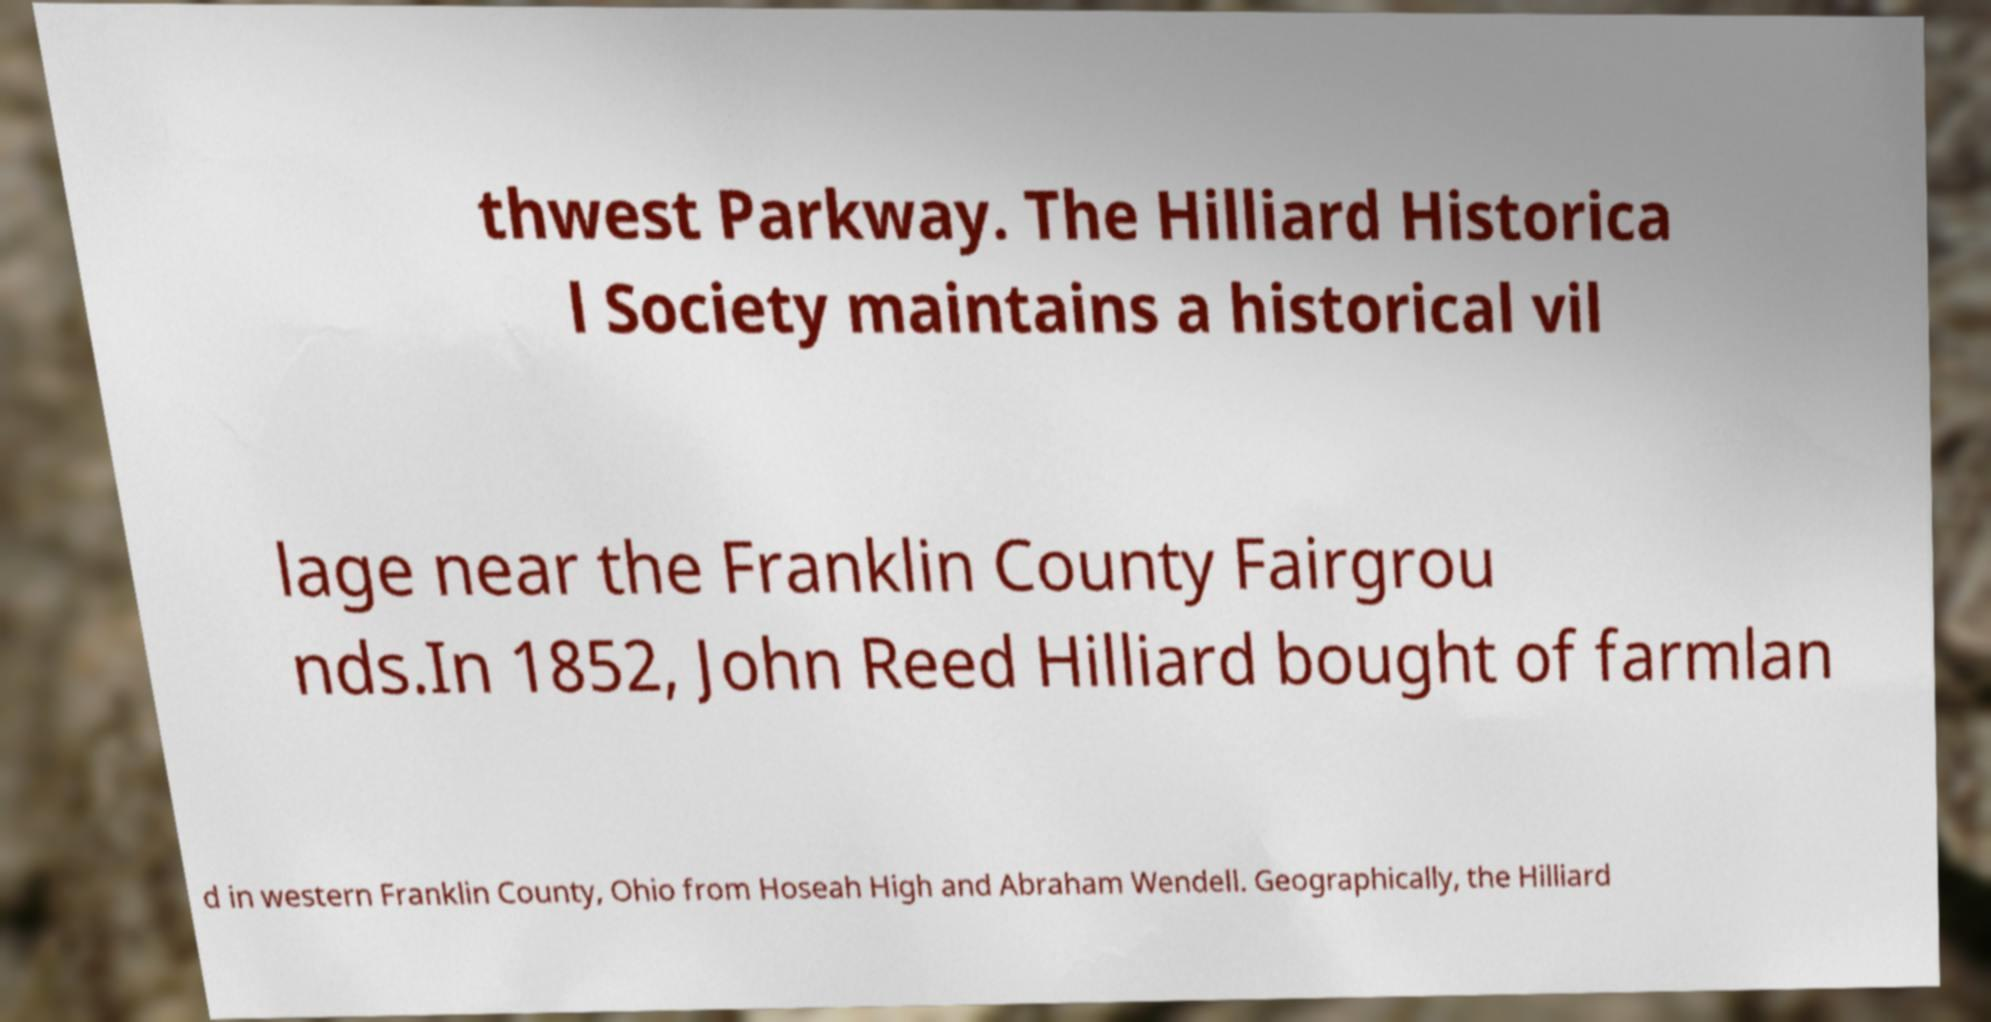Could you assist in decoding the text presented in this image and type it out clearly? thwest Parkway. The Hilliard Historica l Society maintains a historical vil lage near the Franklin County Fairgrou nds.In 1852, John Reed Hilliard bought of farmlan d in western Franklin County, Ohio from Hoseah High and Abraham Wendell. Geographically, the Hilliard 